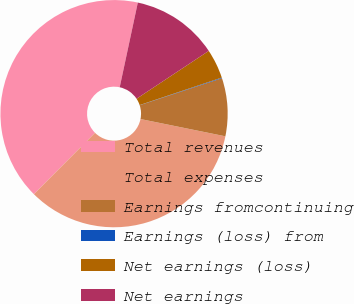<chart> <loc_0><loc_0><loc_500><loc_500><pie_chart><fcel>Total revenues<fcel>Total expenses<fcel>Earnings fromcontinuing<fcel>Earnings (loss) from<fcel>Net earnings (loss)<fcel>Net earnings<nl><fcel>40.89%<fcel>34.28%<fcel>8.25%<fcel>0.09%<fcel>4.17%<fcel>12.33%<nl></chart> 